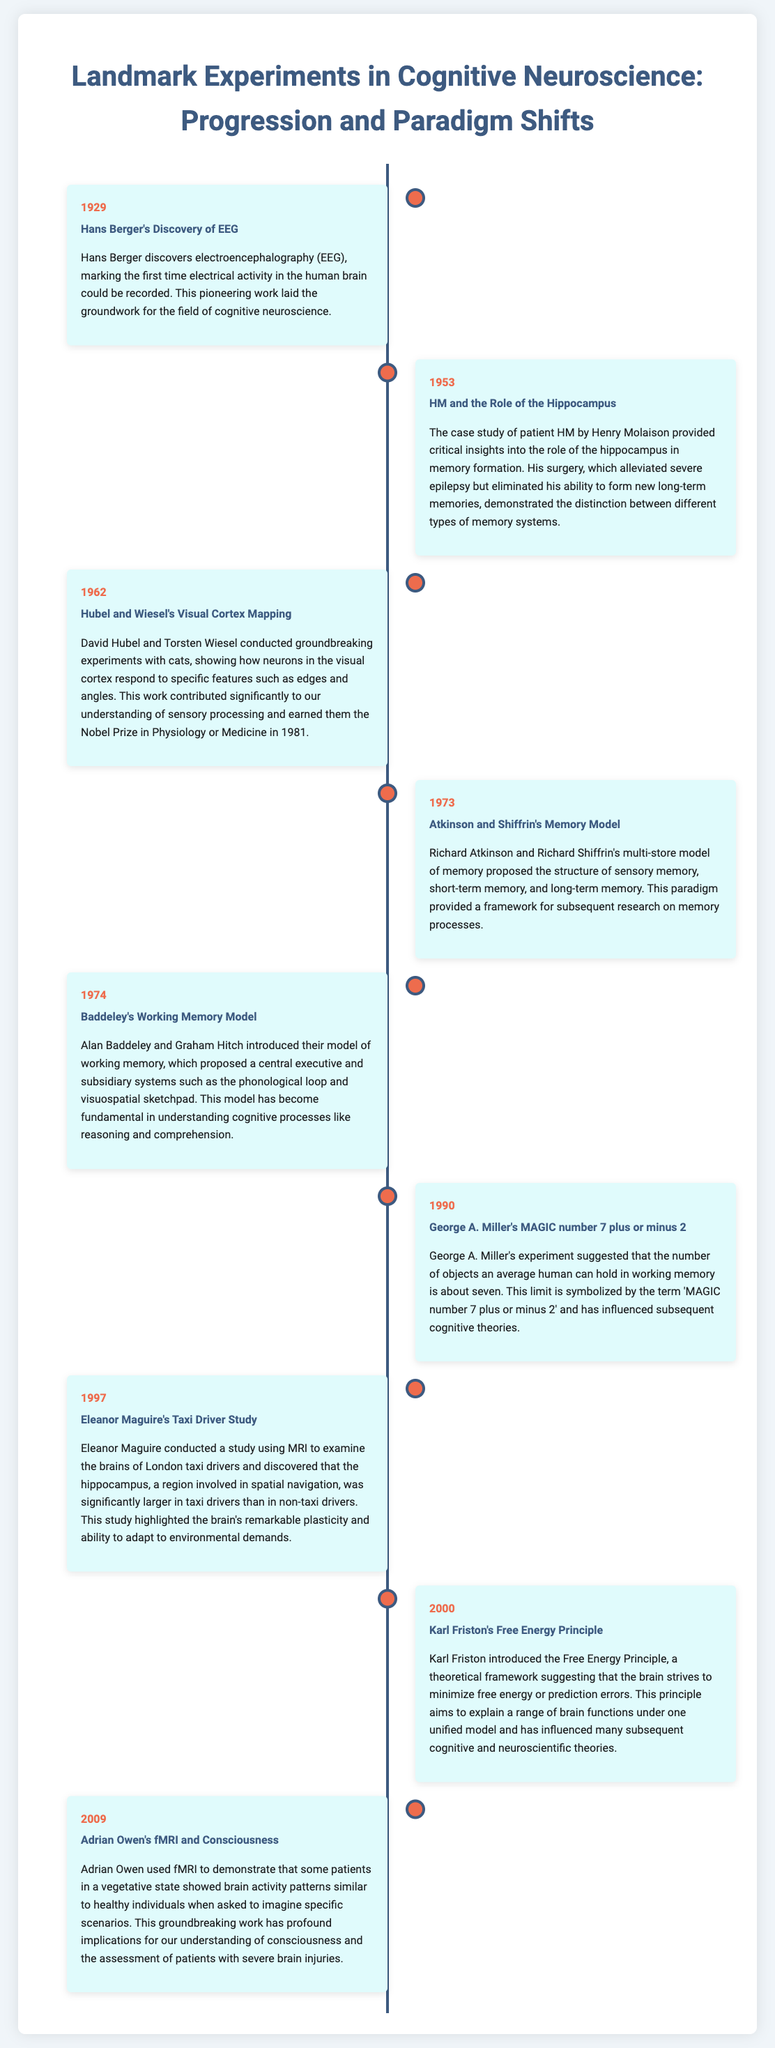what year did Hans Berger discover EEG? The date of Hans Berger's discovery of EEG is specifically mentioned in the timeline section for that experiment.
Answer: 1929 who conducted the taxi driver study? The timeline entry for 1997 specifies that Eleanor Maguire conducted the study examining the brains of London taxi drivers.
Answer: Eleanor Maguire what model did Atkinson and Shiffrin propose in 1973? The content related to Atkinson and Shiffrin in the document clarifies that they proposed a multi-store model of memory.
Answer: multi-store model what is the main focus of Karl Friston's 2000 experiment? The timeline explains that Karl Friston introduced the Free Energy Principle as a theoretical framework, indicating its main focus.
Answer: Free Energy Principle how many objects can the average human hold in working memory according to George A. Miller? The document notes that George A. Miller's research suggested the average number of objects is about seven.
Answer: seven what significant insight did the study of patient HM provide? The entry regarding patient HM gives insight into the role of the hippocampus in memory formation, which is a critical detail.
Answer: role of the hippocampus which prize did Hubel and Wiesel win for their work? The document states that Hubel and Wiesel's work earned them the Nobel Prize in Physiology or Medicine in 1981.
Answer: Nobel Prize what experimental method did Adrian Owen use in 2009? The document specifically mentions that Adrian Owen used fMRI to conduct his groundbreaking work regarding patients in a vegetative state.
Answer: fMRI what did Baddeley's working memory model include? The entry on Baddeley's model highlights that it proposed a central executive and subsidiary systems, therefore indicating what it included.
Answer: central executive and subsidiary systems 